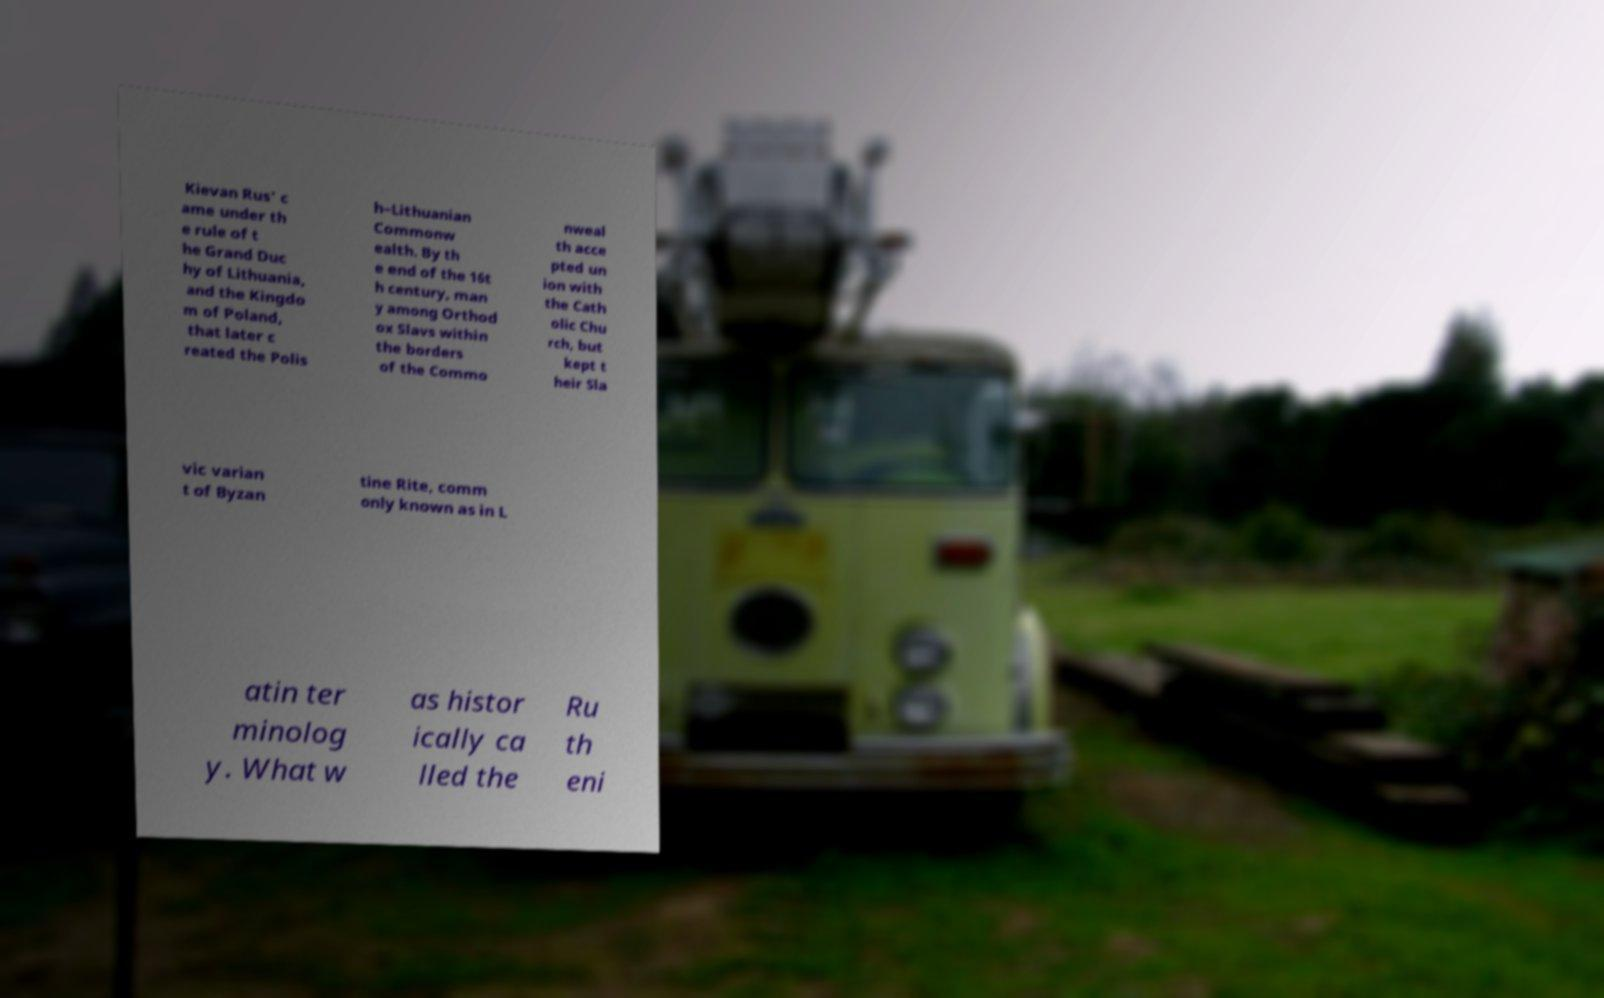What messages or text are displayed in this image? I need them in a readable, typed format. Kievan Rus' c ame under th e rule of t he Grand Duc hy of Lithuania, and the Kingdo m of Poland, that later c reated the Polis h–Lithuanian Commonw ealth. By th e end of the 16t h century, man y among Orthod ox Slavs within the borders of the Commo nweal th acce pted un ion with the Cath olic Chu rch, but kept t heir Sla vic varian t of Byzan tine Rite, comm only known as in L atin ter minolog y. What w as histor ically ca lled the Ru th eni 